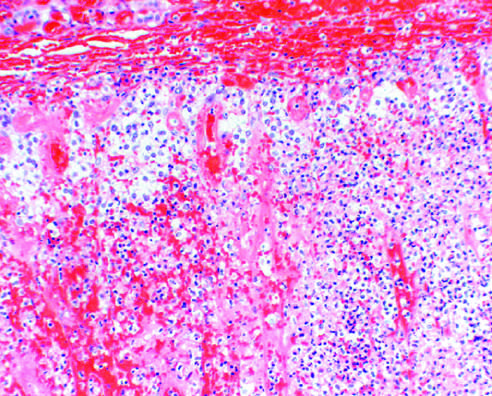did bilateral adrenal hemorrhage in an infant with overwhelming sepsis result in acute adrenal insufficiency?
Answer the question using a single word or phrase. Yes 